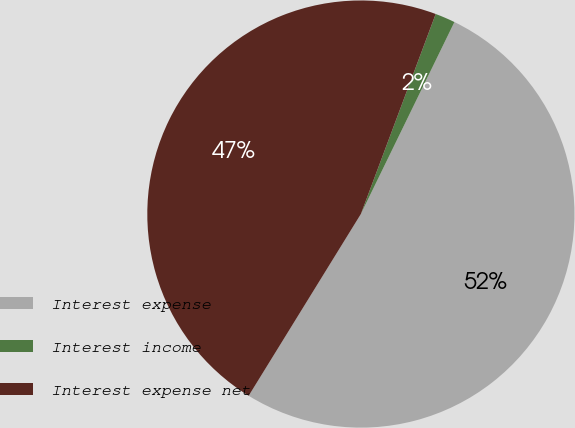Convert chart. <chart><loc_0><loc_0><loc_500><loc_500><pie_chart><fcel>Interest expense<fcel>Interest income<fcel>Interest expense net<nl><fcel>51.59%<fcel>1.52%<fcel>46.9%<nl></chart> 